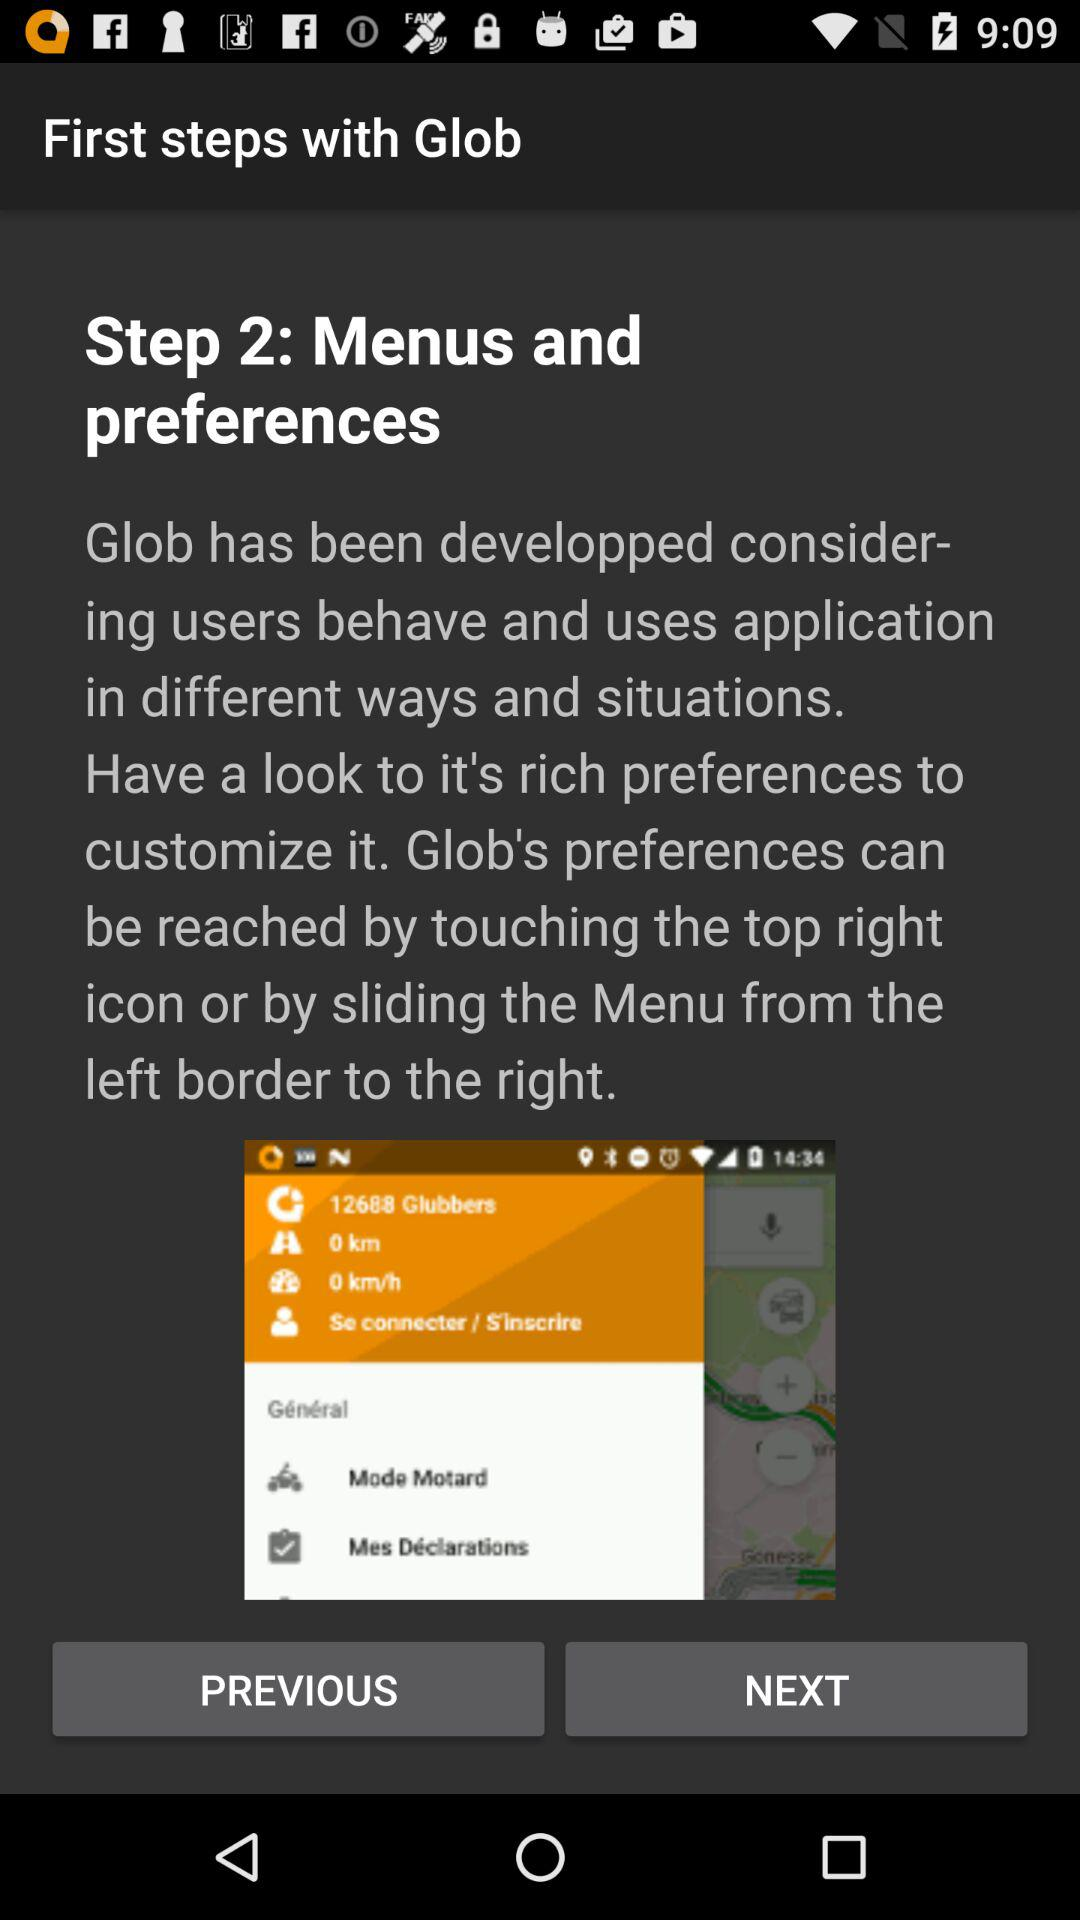How many followers does "Glob" have?
When the provided information is insufficient, respond with <no answer>. <no answer> 